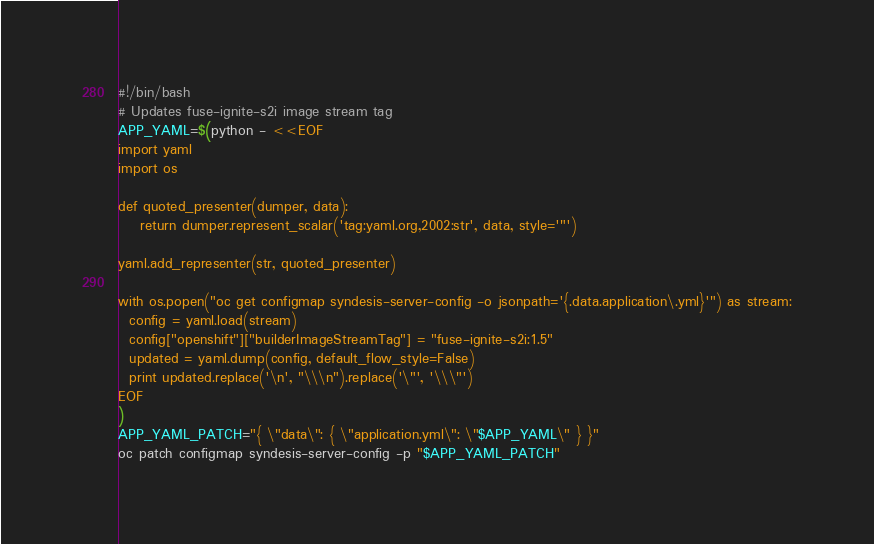<code> <loc_0><loc_0><loc_500><loc_500><_Bash_>#!/bin/bash
# Updates fuse-ignite-s2i image stream tag
APP_YAML=$(python - <<EOF
import yaml
import os

def quoted_presenter(dumper, data):
    return dumper.represent_scalar('tag:yaml.org,2002:str', data, style='"')

yaml.add_representer(str, quoted_presenter)

with os.popen("oc get configmap syndesis-server-config -o jsonpath='{.data.application\.yml}'") as stream:
  config = yaml.load(stream)
  config["openshift"]["builderImageStreamTag"] = "fuse-ignite-s2i:1.5"
  updated = yaml.dump(config, default_flow_style=False)
  print updated.replace('\n', "\\\n").replace('\"', '\\\"')
EOF
)
APP_YAML_PATCH="{ \"data\": { \"application.yml\": \"$APP_YAML\" } }"
oc patch configmap syndesis-server-config -p "$APP_YAML_PATCH"
</code> 